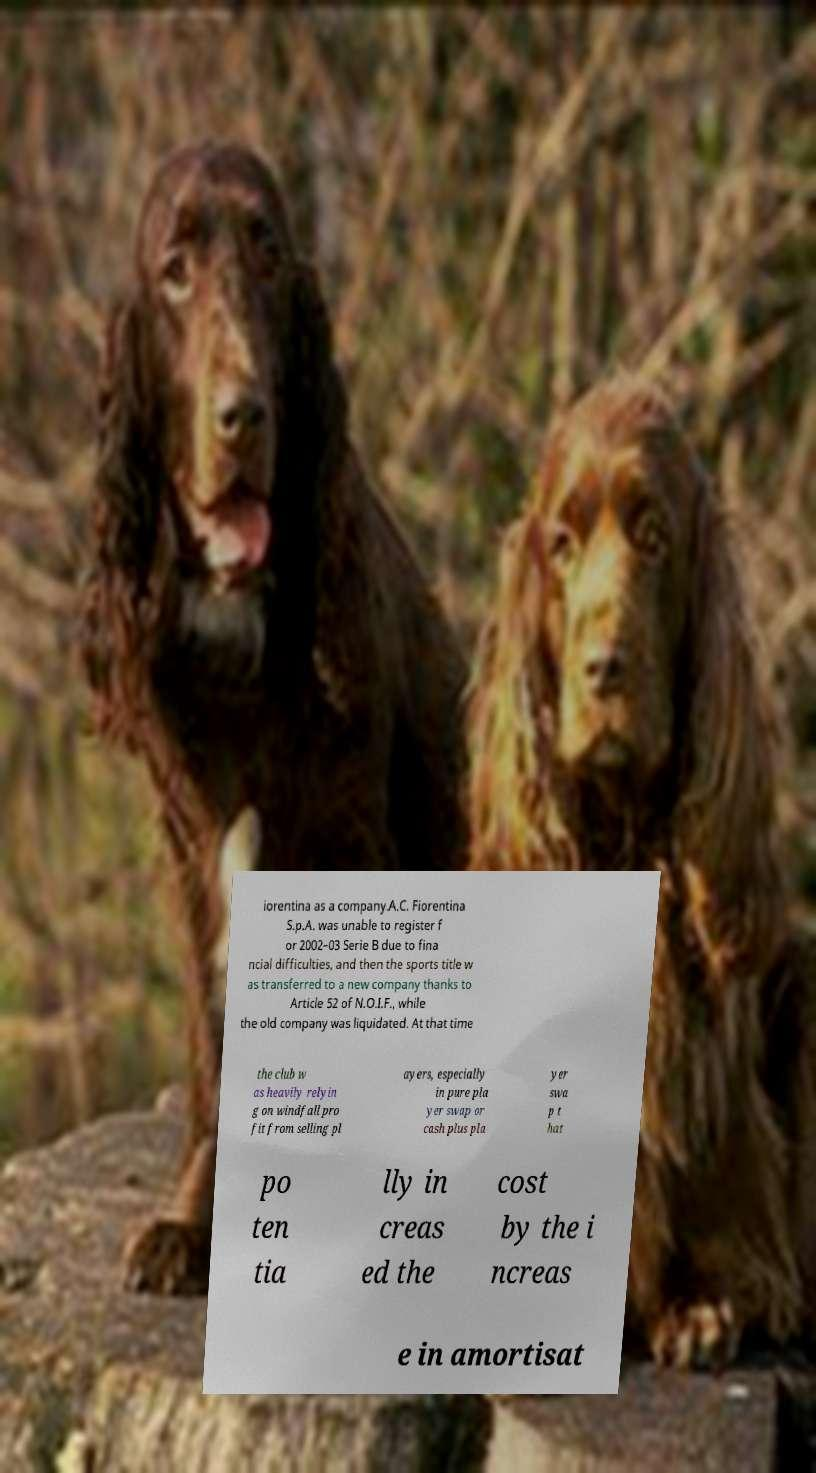I need the written content from this picture converted into text. Can you do that? iorentina as a company.A.C. Fiorentina S.p.A. was unable to register f or 2002–03 Serie B due to fina ncial difficulties, and then the sports title w as transferred to a new company thanks to Article 52 of N.O.I.F., while the old company was liquidated. At that time the club w as heavily relyin g on windfall pro fit from selling pl ayers, especially in pure pla yer swap or cash plus pla yer swa p t hat po ten tia lly in creas ed the cost by the i ncreas e in amortisat 